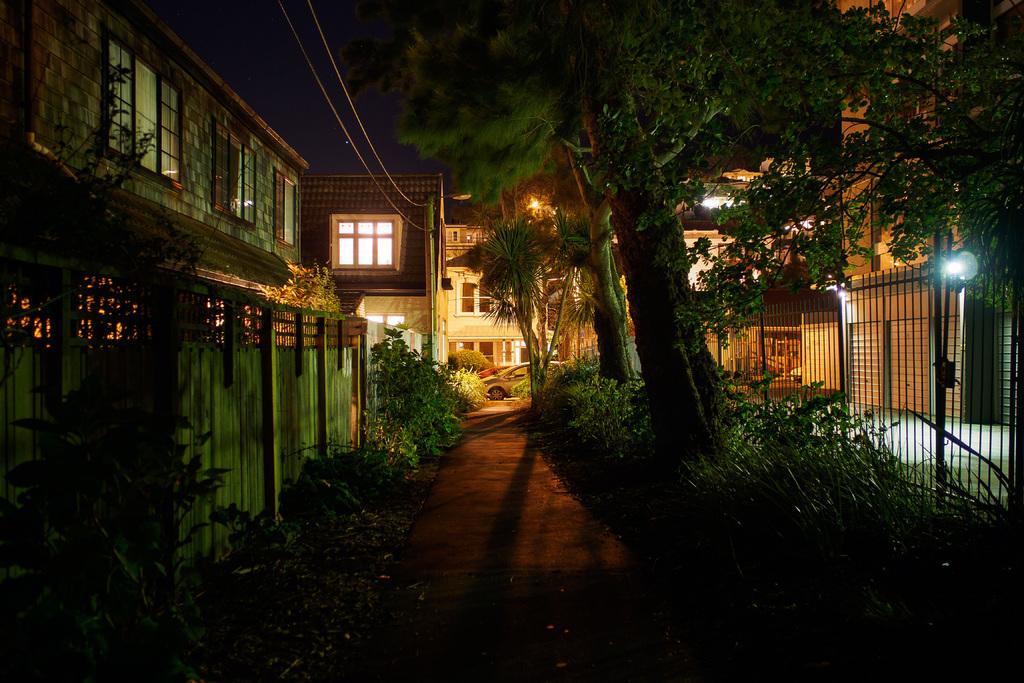In one or two sentences, can you explain what this image depicts? In the image we can see some plants and wall and buildings and poles and lights and trees. In the middle of the image there are some vehicles. 